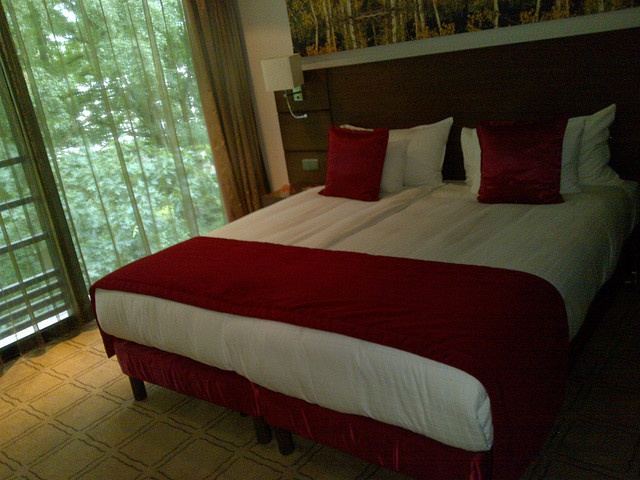Describe the objects in this image and their specific colors. I can see a bed in darkgreen, black, gray, and maroon tones in this image. 